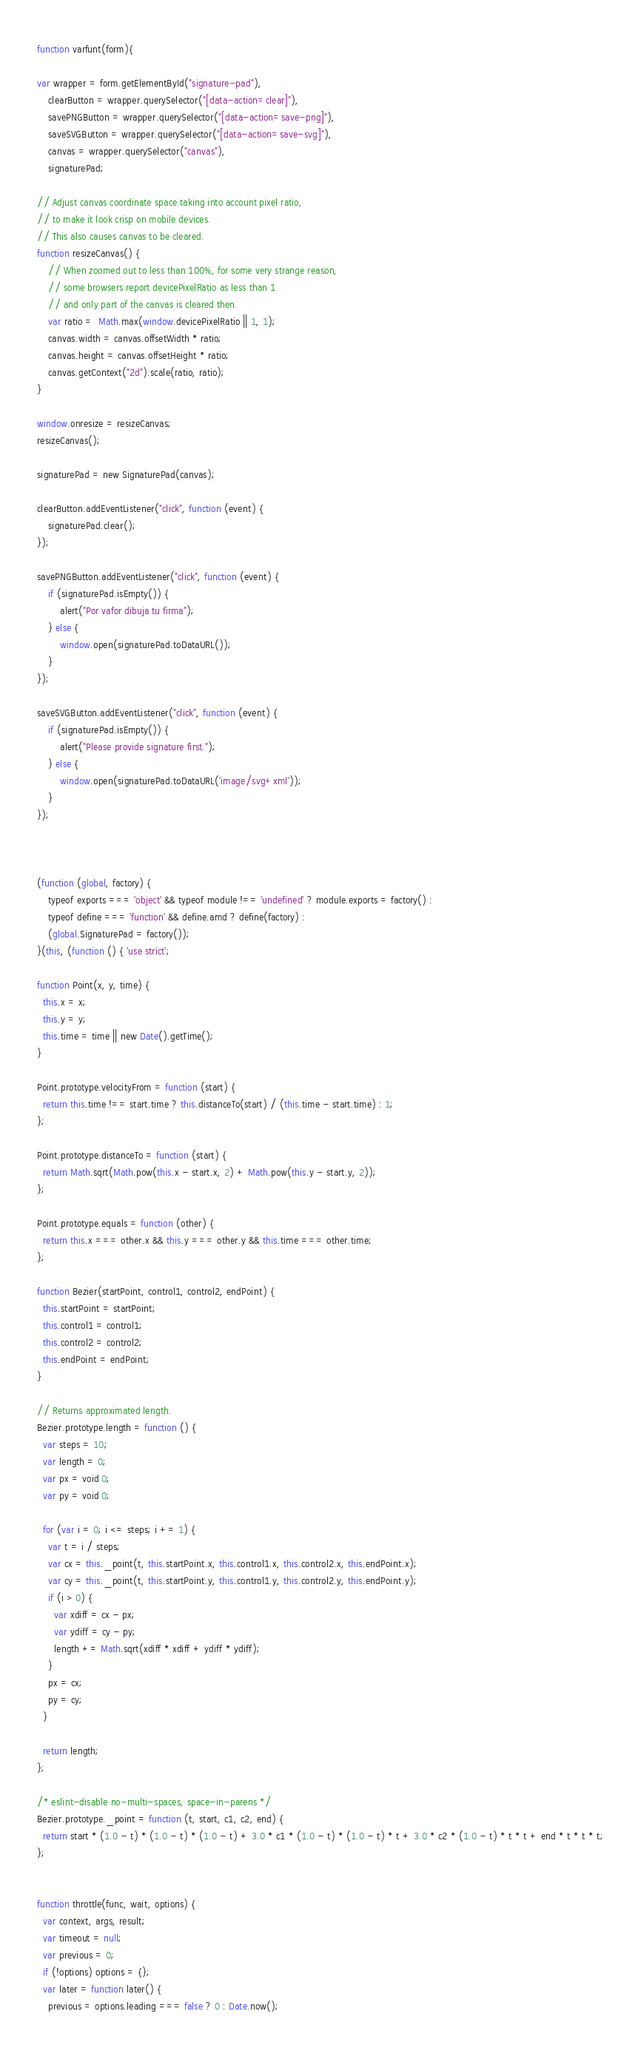<code> <loc_0><loc_0><loc_500><loc_500><_JavaScript_>function varfunt(form){

var wrapper = form.getElementById("signature-pad"),
    clearButton = wrapper.querySelector("[data-action=clear]"),
    savePNGButton = wrapper.querySelector("[data-action=save-png]"),
    saveSVGButton = wrapper.querySelector("[data-action=save-svg]"),
    canvas = wrapper.querySelector("canvas"),
    signaturePad;

// Adjust canvas coordinate space taking into account pixel ratio,
// to make it look crisp on mobile devices.
// This also causes canvas to be cleared.
function resizeCanvas() {
    // When zoomed out to less than 100%, for some very strange reason,
    // some browsers report devicePixelRatio as less than 1
    // and only part of the canvas is cleared then.
    var ratio =  Math.max(window.devicePixelRatio || 1, 1);
    canvas.width = canvas.offsetWidth * ratio;
    canvas.height = canvas.offsetHeight * ratio;
    canvas.getContext("2d").scale(ratio, ratio);
}

window.onresize = resizeCanvas;
resizeCanvas();

signaturePad = new SignaturePad(canvas);

clearButton.addEventListener("click", function (event) {
    signaturePad.clear();
});

savePNGButton.addEventListener("click", function (event) {
    if (signaturePad.isEmpty()) {
        alert("Por vafor dibuja tu firma");
    } else {
        window.open(signaturePad.toDataURL());
    }
});

saveSVGButton.addEventListener("click", function (event) {
    if (signaturePad.isEmpty()) {
        alert("Please provide signature first.");
    } else {
        window.open(signaturePad.toDataURL('image/svg+xml'));
    }
});
  
  
  
(function (global, factory) {
	typeof exports === 'object' && typeof module !== 'undefined' ? module.exports = factory() :
	typeof define === 'function' && define.amd ? define(factory) :
	(global.SignaturePad = factory());
}(this, (function () { 'use strict';

function Point(x, y, time) {
  this.x = x;
  this.y = y;
  this.time = time || new Date().getTime();
}

Point.prototype.velocityFrom = function (start) {
  return this.time !== start.time ? this.distanceTo(start) / (this.time - start.time) : 1;
};

Point.prototype.distanceTo = function (start) {
  return Math.sqrt(Math.pow(this.x - start.x, 2) + Math.pow(this.y - start.y, 2));
};

Point.prototype.equals = function (other) {
  return this.x === other.x && this.y === other.y && this.time === other.time;
};

function Bezier(startPoint, control1, control2, endPoint) {
  this.startPoint = startPoint;
  this.control1 = control1;
  this.control2 = control2;
  this.endPoint = endPoint;
}

// Returns approximated length.
Bezier.prototype.length = function () {
  var steps = 10;
  var length = 0;
  var px = void 0;
  var py = void 0;

  for (var i = 0; i <= steps; i += 1) {
    var t = i / steps;
    var cx = this._point(t, this.startPoint.x, this.control1.x, this.control2.x, this.endPoint.x);
    var cy = this._point(t, this.startPoint.y, this.control1.y, this.control2.y, this.endPoint.y);
    if (i > 0) {
      var xdiff = cx - px;
      var ydiff = cy - py;
      length += Math.sqrt(xdiff * xdiff + ydiff * ydiff);
    }
    px = cx;
    py = cy;
  }

  return length;
};

/* eslint-disable no-multi-spaces, space-in-parens */
Bezier.prototype._point = function (t, start, c1, c2, end) {
  return start * (1.0 - t) * (1.0 - t) * (1.0 - t) + 3.0 * c1 * (1.0 - t) * (1.0 - t) * t + 3.0 * c2 * (1.0 - t) * t * t + end * t * t * t;
};


function throttle(func, wait, options) {
  var context, args, result;
  var timeout = null;
  var previous = 0;
  if (!options) options = {};
  var later = function later() {
    previous = options.leading === false ? 0 : Date.now();</code> 